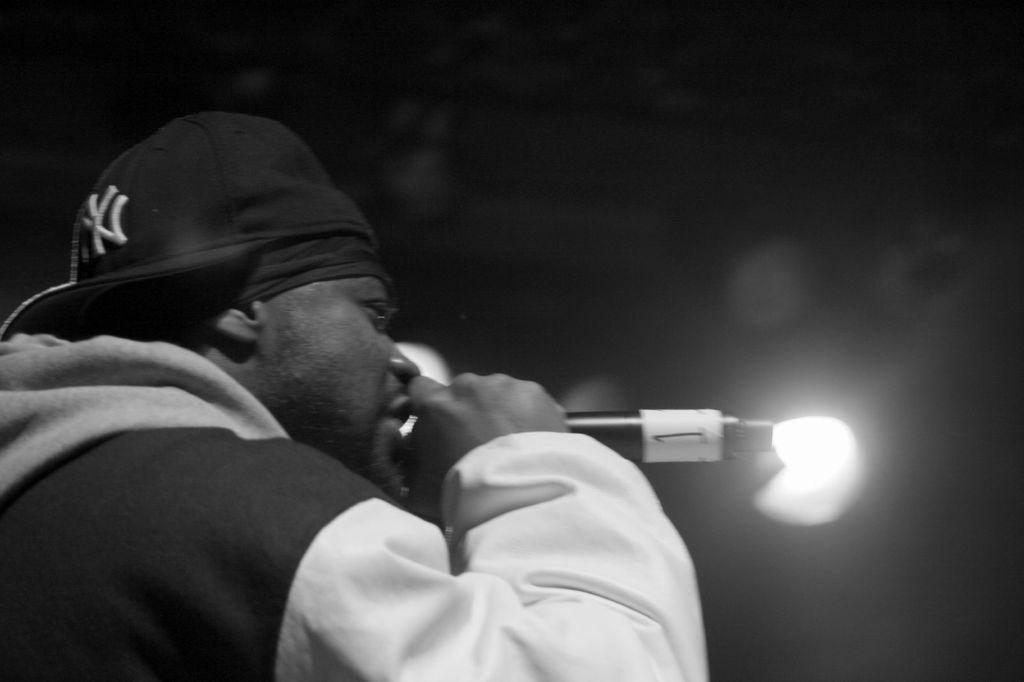What can be seen in the image? There is a person in the image. What is the person wearing? The person is wearing a hat and a jacket. What is the person holding in his hand? The person is holding a microphone in his hand. What can be seen in the background of the image? There is a light in the background of the image, and the background is black. What type of thunder can be heard in the image? There is no thunder present in the image, as it is a still photograph. How many yams are visible in the image? There are no yams present in the image. 